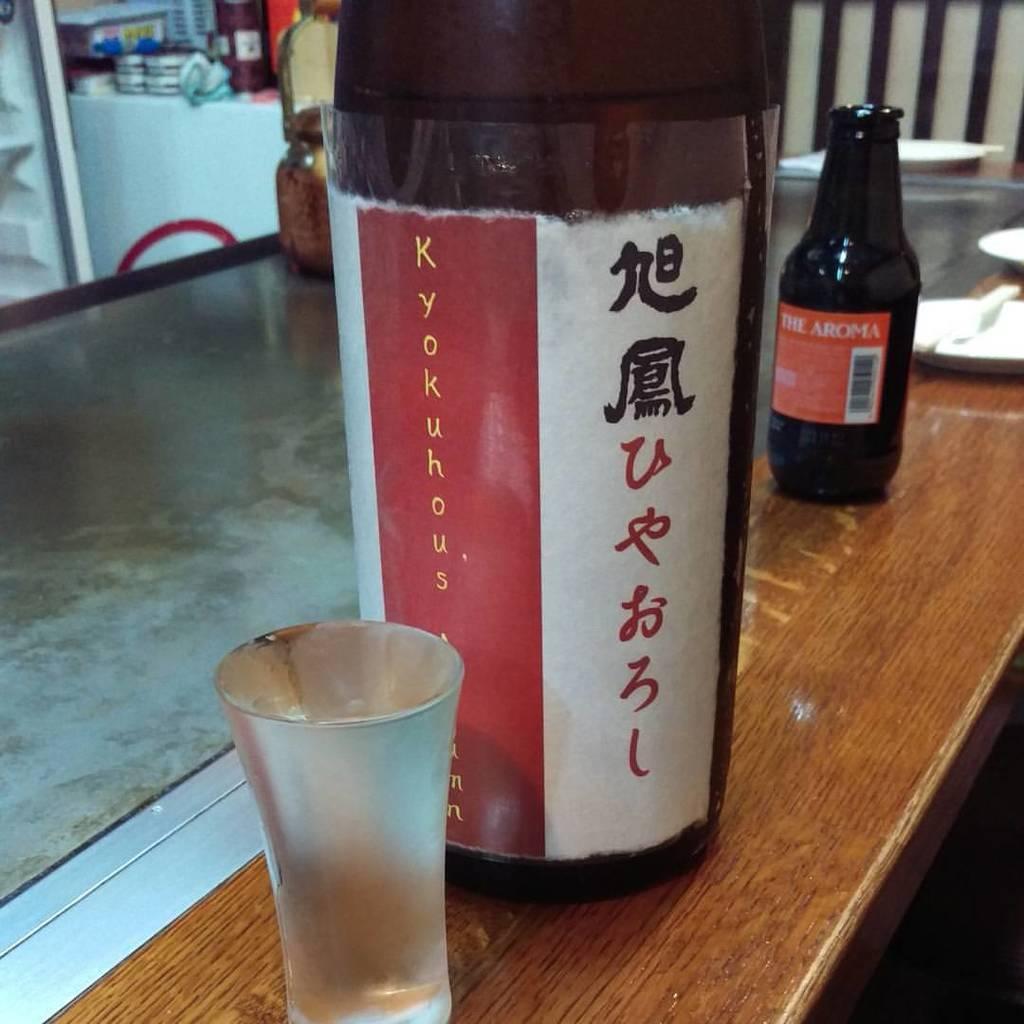Please provide a concise description of this image. In this picture a wooden bottle is kept on the table and beside it we observe a glass bottle and an empty glass. In the background we observe plates,and other containers. On the wooden bottle there is a label attached named as kyokuhous. 